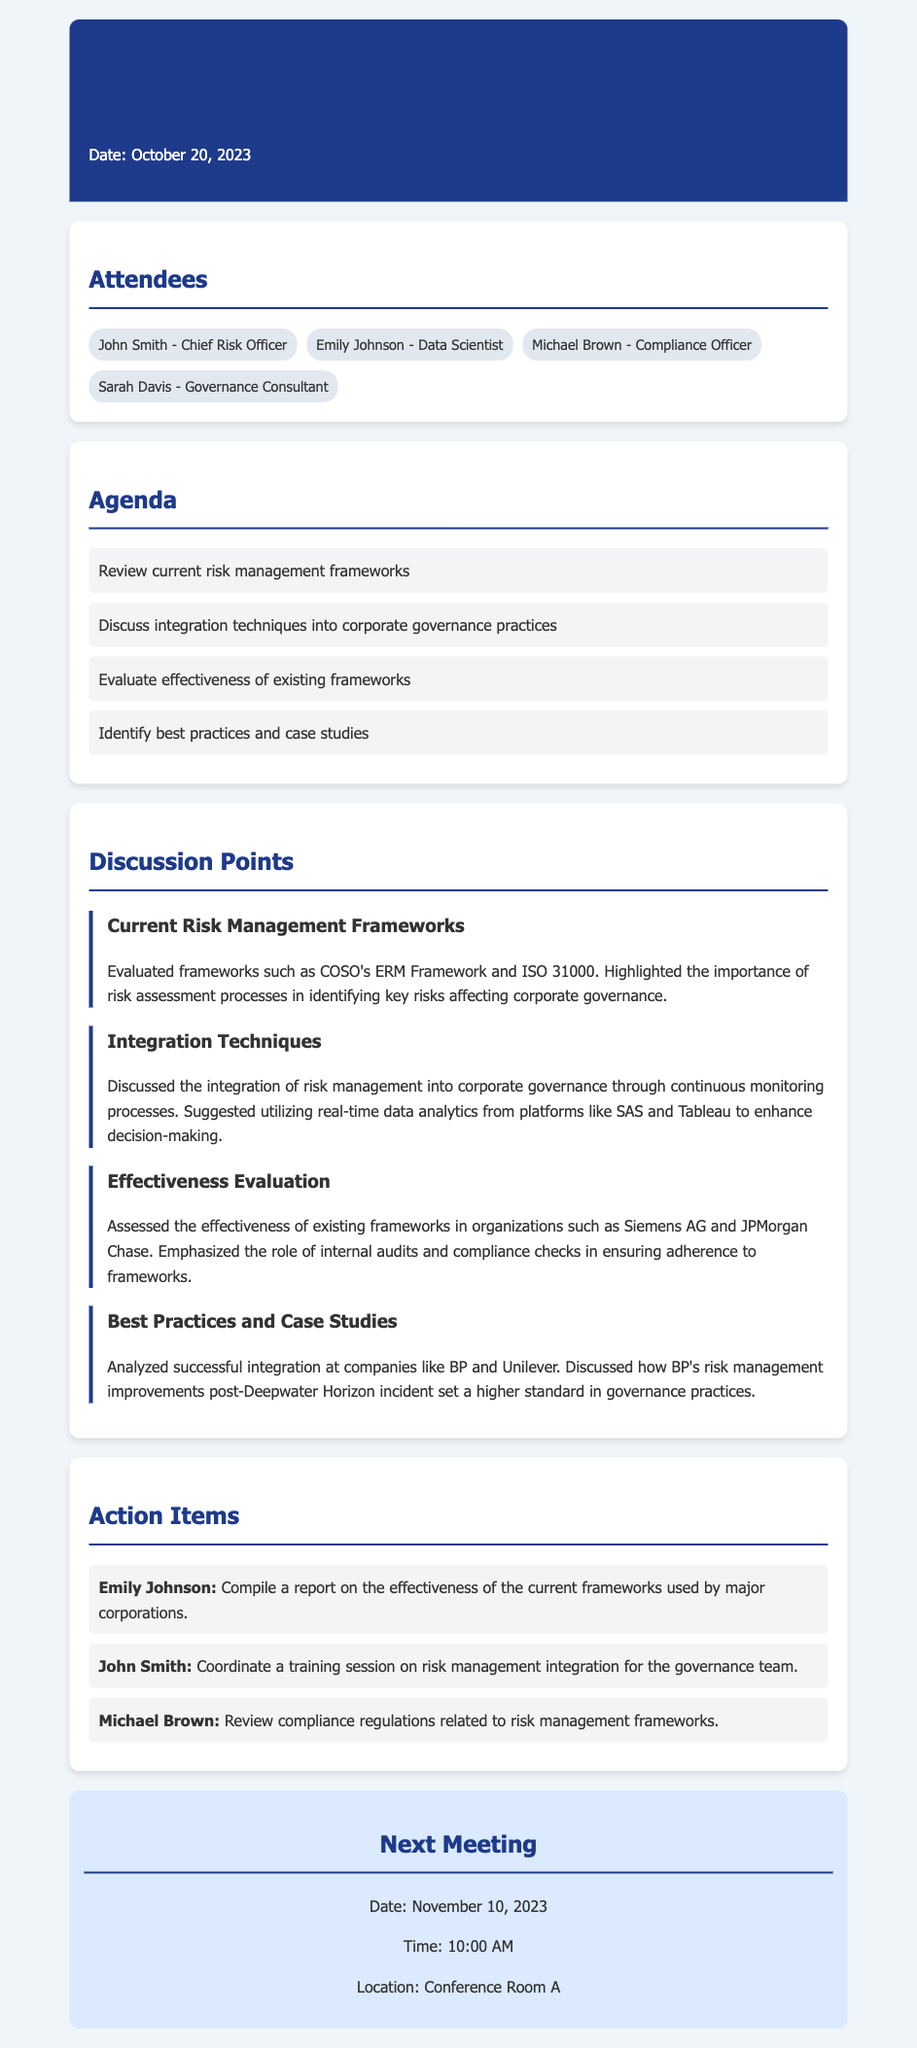What is the date of the meeting? The date of the meeting is explicitly provided in the document.
Answer: October 20, 2023 Who is the Chief Risk Officer? The document lists attendees that specify roles, including the Chief Risk Officer.
Answer: John Smith What were the first two agenda items? The agenda lists multiple items, and the first two are directly mentioned in the document.
Answer: Review current risk management frameworks, Discuss integration techniques into corporate governance practices Which risk management frameworks were evaluated? The discussion point regarding current frameworks names specific frameworks that were evaluated.
Answer: COSO's ERM Framework and ISO 31000 What action item is assigned to Emily Johnson? The action items section specifies tasks assigned to each attendee.
Answer: Compile a report on the effectiveness of the current frameworks used by major corporations How many attendees are listed? The attendees section provides a count of participants at the meeting.
Answer: Four What company is mentioned as having successful integration post-incident? The discussion point on best practices references a specific company and incident.
Answer: BP What is the location of the next meeting? The next meeting section indicates where the future meeting will take place.
Answer: Conference Room A 